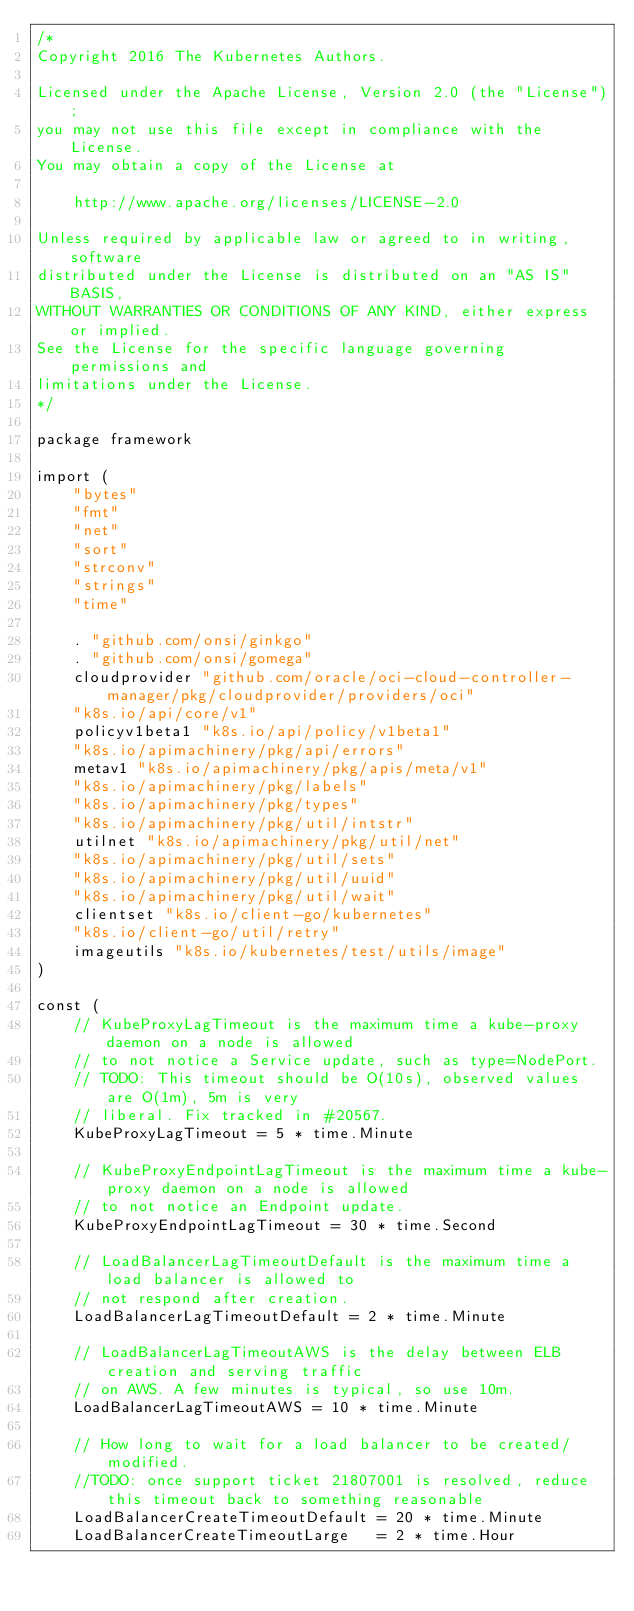<code> <loc_0><loc_0><loc_500><loc_500><_Go_>/*
Copyright 2016 The Kubernetes Authors.

Licensed under the Apache License, Version 2.0 (the "License");
you may not use this file except in compliance with the License.
You may obtain a copy of the License at

    http://www.apache.org/licenses/LICENSE-2.0

Unless required by applicable law or agreed to in writing, software
distributed under the License is distributed on an "AS IS" BASIS,
WITHOUT WARRANTIES OR CONDITIONS OF ANY KIND, either express or implied.
See the License for the specific language governing permissions and
limitations under the License.
*/

package framework

import (
	"bytes"
	"fmt"
	"net"
	"sort"
	"strconv"
	"strings"
	"time"

	. "github.com/onsi/ginkgo"
	. "github.com/onsi/gomega"
	cloudprovider "github.com/oracle/oci-cloud-controller-manager/pkg/cloudprovider/providers/oci"
	"k8s.io/api/core/v1"
	policyv1beta1 "k8s.io/api/policy/v1beta1"
	"k8s.io/apimachinery/pkg/api/errors"
	metav1 "k8s.io/apimachinery/pkg/apis/meta/v1"
	"k8s.io/apimachinery/pkg/labels"
	"k8s.io/apimachinery/pkg/types"
	"k8s.io/apimachinery/pkg/util/intstr"
	utilnet "k8s.io/apimachinery/pkg/util/net"
	"k8s.io/apimachinery/pkg/util/sets"
	"k8s.io/apimachinery/pkg/util/uuid"
	"k8s.io/apimachinery/pkg/util/wait"
	clientset "k8s.io/client-go/kubernetes"
	"k8s.io/client-go/util/retry"
	imageutils "k8s.io/kubernetes/test/utils/image"
)

const (
	// KubeProxyLagTimeout is the maximum time a kube-proxy daemon on a node is allowed
	// to not notice a Service update, such as type=NodePort.
	// TODO: This timeout should be O(10s), observed values are O(1m), 5m is very
	// liberal. Fix tracked in #20567.
	KubeProxyLagTimeout = 5 * time.Minute

	// KubeProxyEndpointLagTimeout is the maximum time a kube-proxy daemon on a node is allowed
	// to not notice an Endpoint update.
	KubeProxyEndpointLagTimeout = 30 * time.Second

	// LoadBalancerLagTimeoutDefault is the maximum time a load balancer is allowed to
	// not respond after creation.
	LoadBalancerLagTimeoutDefault = 2 * time.Minute

	// LoadBalancerLagTimeoutAWS is the delay between ELB creation and serving traffic
	// on AWS. A few minutes is typical, so use 10m.
	LoadBalancerLagTimeoutAWS = 10 * time.Minute

	// How long to wait for a load balancer to be created/modified.
	//TODO: once support ticket 21807001 is resolved, reduce this timeout back to something reasonable
	LoadBalancerCreateTimeoutDefault = 20 * time.Minute
	LoadBalancerCreateTimeoutLarge   = 2 * time.Hour
</code> 